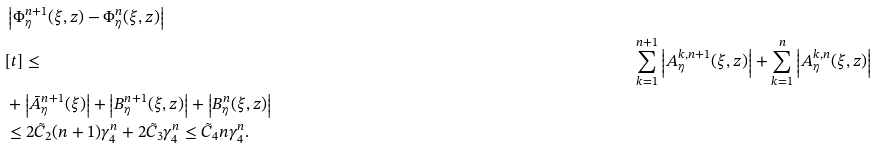Convert formula to latex. <formula><loc_0><loc_0><loc_500><loc_500>& \left | \Phi _ { \eta } ^ { n + 1 } ( \xi , z ) - \Phi _ { \eta } ^ { n } ( \xi , z ) \right | \\ & [ t ] \leq & \sum _ { k = 1 } ^ { n + 1 } \left | A _ { \eta } ^ { k , n + 1 } ( \xi , z ) \right | + \sum _ { k = 1 } ^ { n } \left | A _ { \eta } ^ { k , n } ( \xi , z ) \right | \\ & + \left | \bar { A } _ { \eta } ^ { n + 1 } ( \xi ) \right | + \left | B _ { \eta } ^ { n + 1 } ( \xi , z ) \right | + \left | B _ { \eta } ^ { n } ( \xi , z ) \right | \\ & \leq 2 \tilde { C } _ { 2 } ( n + 1 ) \gamma _ { 4 } ^ { n } + 2 \tilde { C } _ { 3 } \gamma _ { 4 } ^ { n } \leq \tilde { C } _ { 4 } n \gamma _ { 4 } ^ { n } .</formula> 